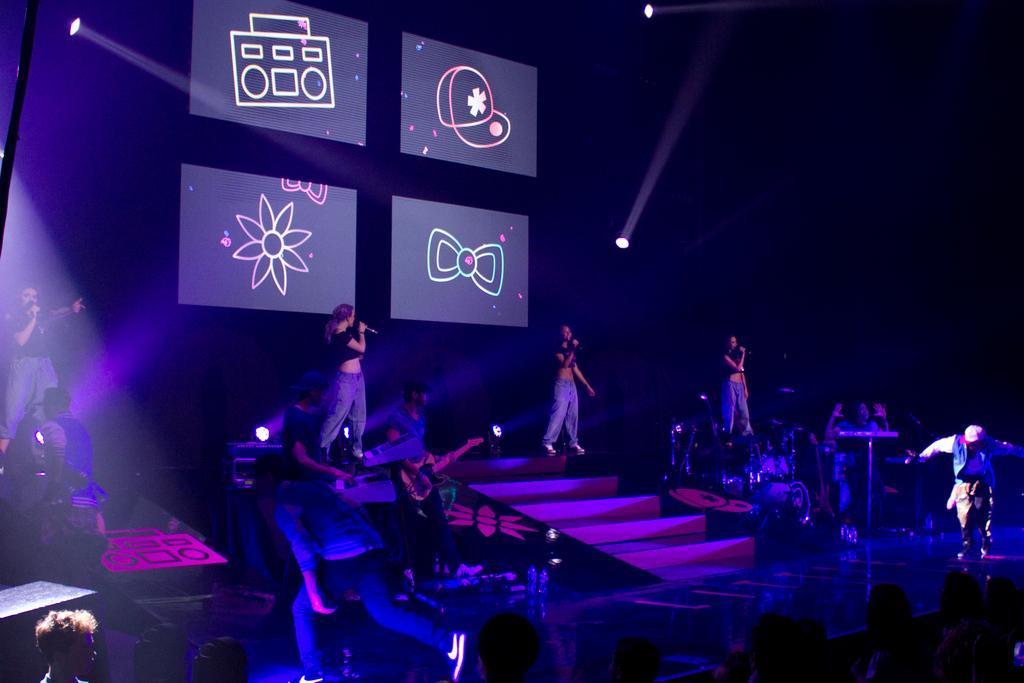Describe this image in one or two sentences. In this image we can see there are a few people standing on the stage and holding mic and a few people playing musical instruments and a few people dancing. And at the back we can see the screen and lights. And there are people standing near the stage. 